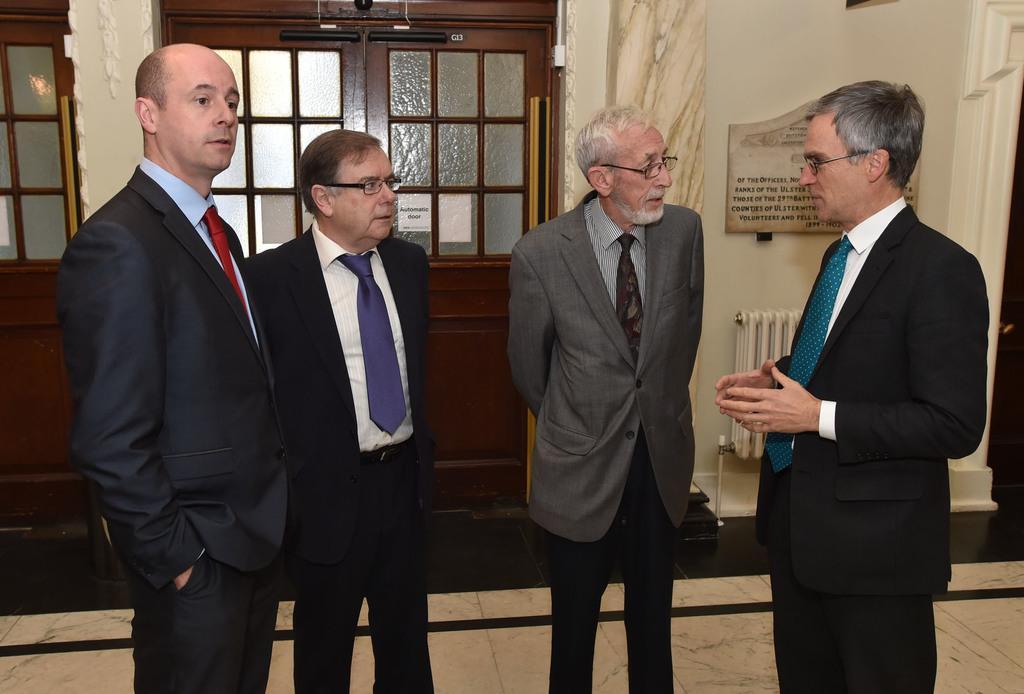How would you summarize this image in a sentence or two? In this image I can see a group of people standing on the floor. On the right side, I can see a board with some text written on it. In the background, I can see the doors. 